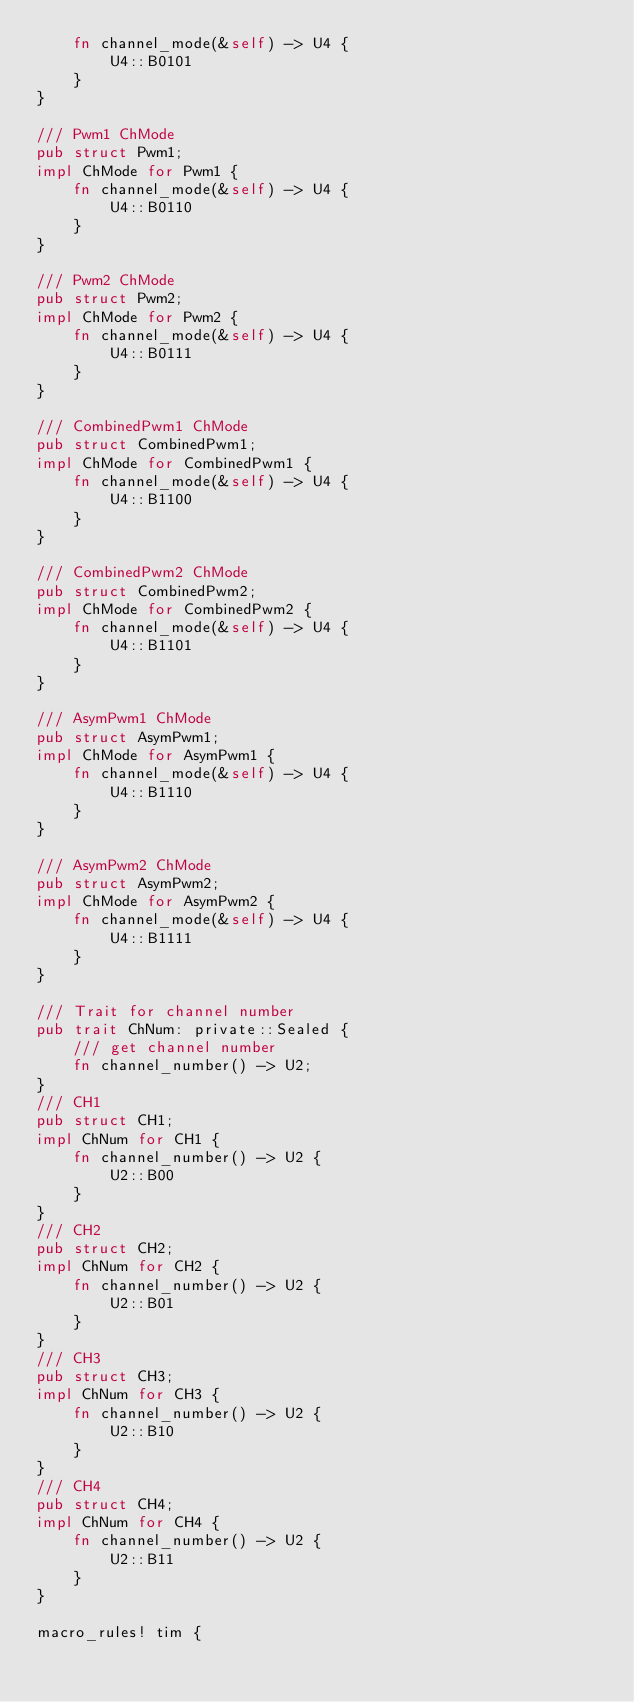Convert code to text. <code><loc_0><loc_0><loc_500><loc_500><_Rust_>    fn channel_mode(&self) -> U4 {
        U4::B0101
    }
}

/// Pwm1 ChMode
pub struct Pwm1;
impl ChMode for Pwm1 {
    fn channel_mode(&self) -> U4 {
        U4::B0110
    }
}

/// Pwm2 ChMode
pub struct Pwm2;
impl ChMode for Pwm2 {
    fn channel_mode(&self) -> U4 {
        U4::B0111
    }
}

/// CombinedPwm1 ChMode
pub struct CombinedPwm1;
impl ChMode for CombinedPwm1 {
    fn channel_mode(&self) -> U4 {
        U4::B1100
    }
}

/// CombinedPwm2 ChMode
pub struct CombinedPwm2;
impl ChMode for CombinedPwm2 {
    fn channel_mode(&self) -> U4 {
        U4::B1101
    }
}

/// AsymPwm1 ChMode
pub struct AsymPwm1;
impl ChMode for AsymPwm1 {
    fn channel_mode(&self) -> U4 {
        U4::B1110
    }
}

/// AsymPwm2 ChMode
pub struct AsymPwm2;
impl ChMode for AsymPwm2 {
    fn channel_mode(&self) -> U4 {
        U4::B1111
    }
}

/// Trait for channel number
pub trait ChNum: private::Sealed {
    /// get channel number
    fn channel_number() -> U2;
}
/// CH1
pub struct CH1;
impl ChNum for CH1 {
    fn channel_number() -> U2 {
        U2::B00
    }
}
/// CH2
pub struct CH2;
impl ChNum for CH2 {
    fn channel_number() -> U2 {
        U2::B01
    }
}
/// CH3
pub struct CH3;
impl ChNum for CH3 {
    fn channel_number() -> U2 {
        U2::B10
    }
}
/// CH4
pub struct CH4;
impl ChNum for CH4 {
    fn channel_number() -> U2 {
        U2::B11
    }
}

macro_rules! tim {</code> 